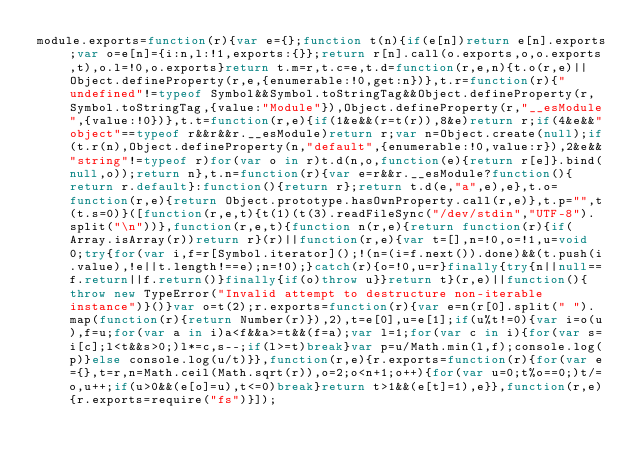<code> <loc_0><loc_0><loc_500><loc_500><_JavaScript_>module.exports=function(r){var e={};function t(n){if(e[n])return e[n].exports;var o=e[n]={i:n,l:!1,exports:{}};return r[n].call(o.exports,o,o.exports,t),o.l=!0,o.exports}return t.m=r,t.c=e,t.d=function(r,e,n){t.o(r,e)||Object.defineProperty(r,e,{enumerable:!0,get:n})},t.r=function(r){"undefined"!=typeof Symbol&&Symbol.toStringTag&&Object.defineProperty(r,Symbol.toStringTag,{value:"Module"}),Object.defineProperty(r,"__esModule",{value:!0})},t.t=function(r,e){if(1&e&&(r=t(r)),8&e)return r;if(4&e&&"object"==typeof r&&r&&r.__esModule)return r;var n=Object.create(null);if(t.r(n),Object.defineProperty(n,"default",{enumerable:!0,value:r}),2&e&&"string"!=typeof r)for(var o in r)t.d(n,o,function(e){return r[e]}.bind(null,o));return n},t.n=function(r){var e=r&&r.__esModule?function(){return r.default}:function(){return r};return t.d(e,"a",e),e},t.o=function(r,e){return Object.prototype.hasOwnProperty.call(r,e)},t.p="",t(t.s=0)}([function(r,e,t){t(1)(t(3).readFileSync("/dev/stdin","UTF-8").split("\n"))},function(r,e,t){function n(r,e){return function(r){if(Array.isArray(r))return r}(r)||function(r,e){var t=[],n=!0,o=!1,u=void 0;try{for(var i,f=r[Symbol.iterator]();!(n=(i=f.next()).done)&&(t.push(i.value),!e||t.length!==e);n=!0);}catch(r){o=!0,u=r}finally{try{n||null==f.return||f.return()}finally{if(o)throw u}}return t}(r,e)||function(){throw new TypeError("Invalid attempt to destructure non-iterable instance")}()}var o=t(2);r.exports=function(r){var e=n(r[0].split(" ").map(function(r){return Number(r)}),2),t=e[0],u=e[1];if(u%t!=0){var i=o(u),f=u;for(var a in i)a<f&&a>=t&&(f=a);var l=1;for(var c in i){for(var s=i[c];l<t&&s>0;)l*=c,s--;if(l>=t)break}var p=u/Math.min(l,f);console.log(p)}else console.log(u/t)}},function(r,e){r.exports=function(r){for(var e={},t=r,n=Math.ceil(Math.sqrt(r)),o=2;o<n+1;o++){for(var u=0;t%o==0;)t/=o,u++;if(u>0&&(e[o]=u),t<=0)break}return t>1&&(e[t]=1),e}},function(r,e){r.exports=require("fs")}]);</code> 